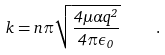Convert formula to latex. <formula><loc_0><loc_0><loc_500><loc_500>k = n \pi \sqrt { \frac { 4 \mu \alpha q ^ { 2 } } { 4 \pi \epsilon _ { 0 } } } \quad .</formula> 